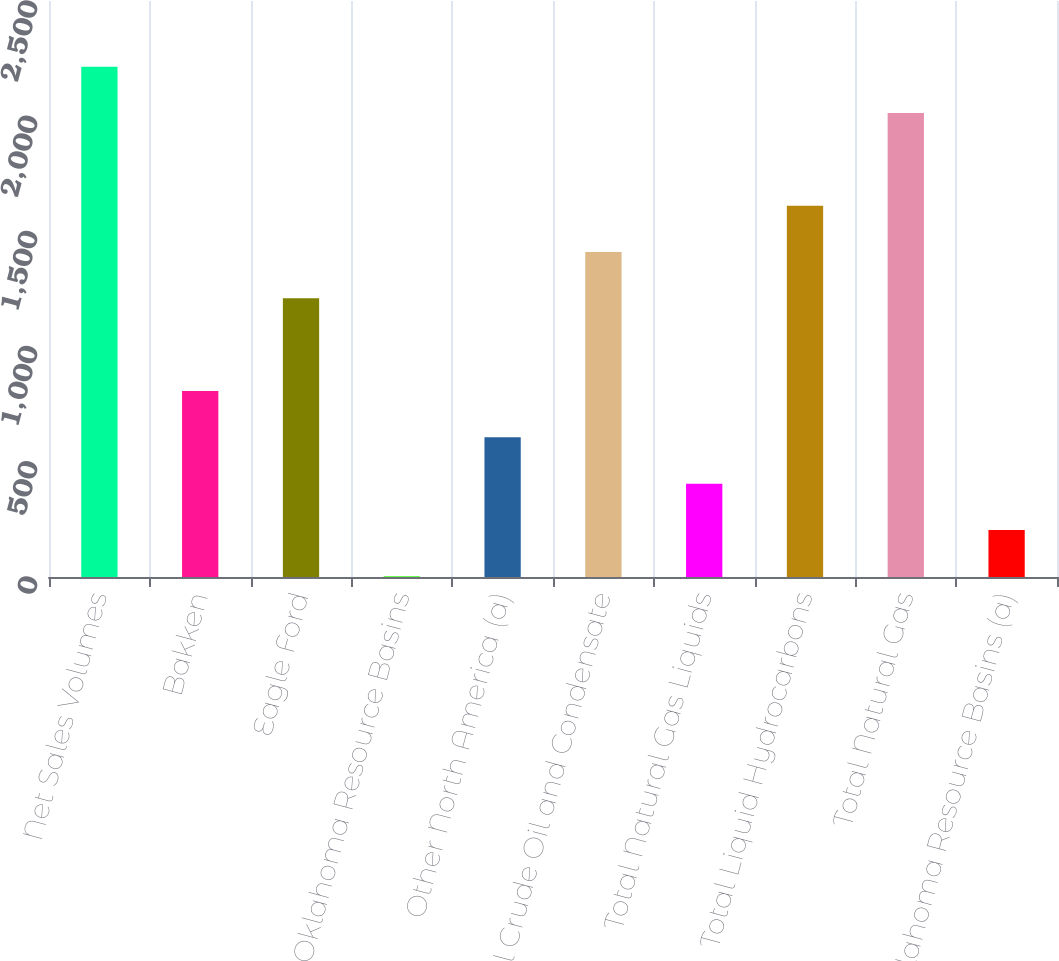<chart> <loc_0><loc_0><loc_500><loc_500><bar_chart><fcel>Net Sales Volumes<fcel>Bakken<fcel>Eagle Ford<fcel>Oklahoma Resource Basins<fcel>Other North America (a)<fcel>Total Crude Oil and Condensate<fcel>Total Natural Gas Liquids<fcel>Total Liquid Hydrocarbons<fcel>Total Natural Gas<fcel>Oklahoma Resource Basins (a)<nl><fcel>2215.1<fcel>807.4<fcel>1209.6<fcel>3<fcel>606.3<fcel>1410.7<fcel>405.2<fcel>1611.8<fcel>2014<fcel>204.1<nl></chart> 